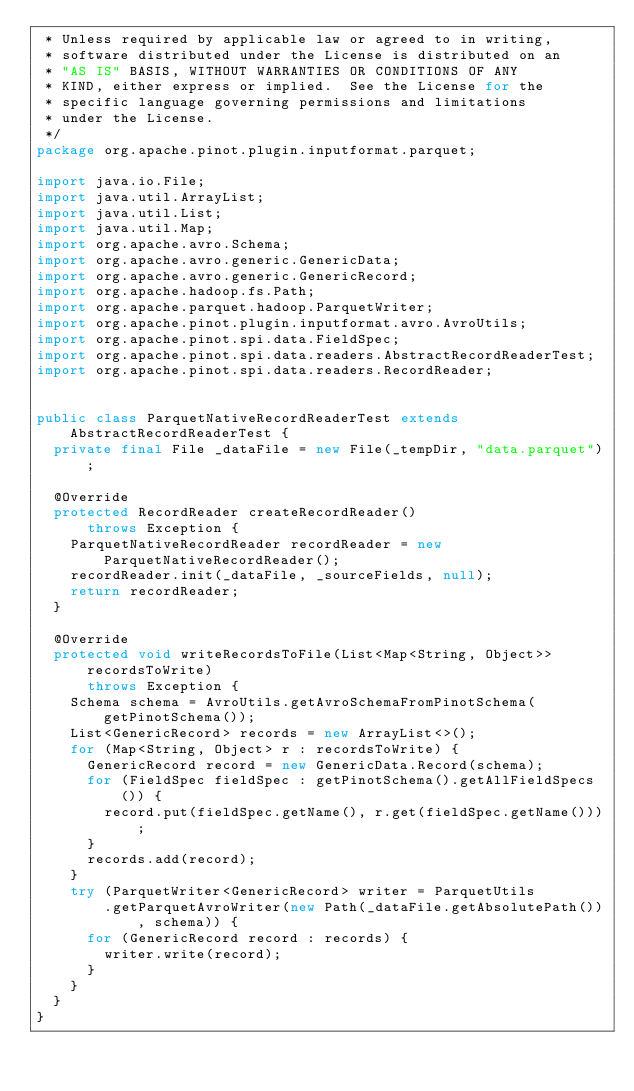Convert code to text. <code><loc_0><loc_0><loc_500><loc_500><_Java_> * Unless required by applicable law or agreed to in writing,
 * software distributed under the License is distributed on an
 * "AS IS" BASIS, WITHOUT WARRANTIES OR CONDITIONS OF ANY
 * KIND, either express or implied.  See the License for the
 * specific language governing permissions and limitations
 * under the License.
 */
package org.apache.pinot.plugin.inputformat.parquet;

import java.io.File;
import java.util.ArrayList;
import java.util.List;
import java.util.Map;
import org.apache.avro.Schema;
import org.apache.avro.generic.GenericData;
import org.apache.avro.generic.GenericRecord;
import org.apache.hadoop.fs.Path;
import org.apache.parquet.hadoop.ParquetWriter;
import org.apache.pinot.plugin.inputformat.avro.AvroUtils;
import org.apache.pinot.spi.data.FieldSpec;
import org.apache.pinot.spi.data.readers.AbstractRecordReaderTest;
import org.apache.pinot.spi.data.readers.RecordReader;


public class ParquetNativeRecordReaderTest extends AbstractRecordReaderTest {
  private final File _dataFile = new File(_tempDir, "data.parquet");

  @Override
  protected RecordReader createRecordReader()
      throws Exception {
    ParquetNativeRecordReader recordReader = new ParquetNativeRecordReader();
    recordReader.init(_dataFile, _sourceFields, null);
    return recordReader;
  }

  @Override
  protected void writeRecordsToFile(List<Map<String, Object>> recordsToWrite)
      throws Exception {
    Schema schema = AvroUtils.getAvroSchemaFromPinotSchema(getPinotSchema());
    List<GenericRecord> records = new ArrayList<>();
    for (Map<String, Object> r : recordsToWrite) {
      GenericRecord record = new GenericData.Record(schema);
      for (FieldSpec fieldSpec : getPinotSchema().getAllFieldSpecs()) {
        record.put(fieldSpec.getName(), r.get(fieldSpec.getName()));
      }
      records.add(record);
    }
    try (ParquetWriter<GenericRecord> writer = ParquetUtils
        .getParquetAvroWriter(new Path(_dataFile.getAbsolutePath()), schema)) {
      for (GenericRecord record : records) {
        writer.write(record);
      }
    }
  }
}
</code> 